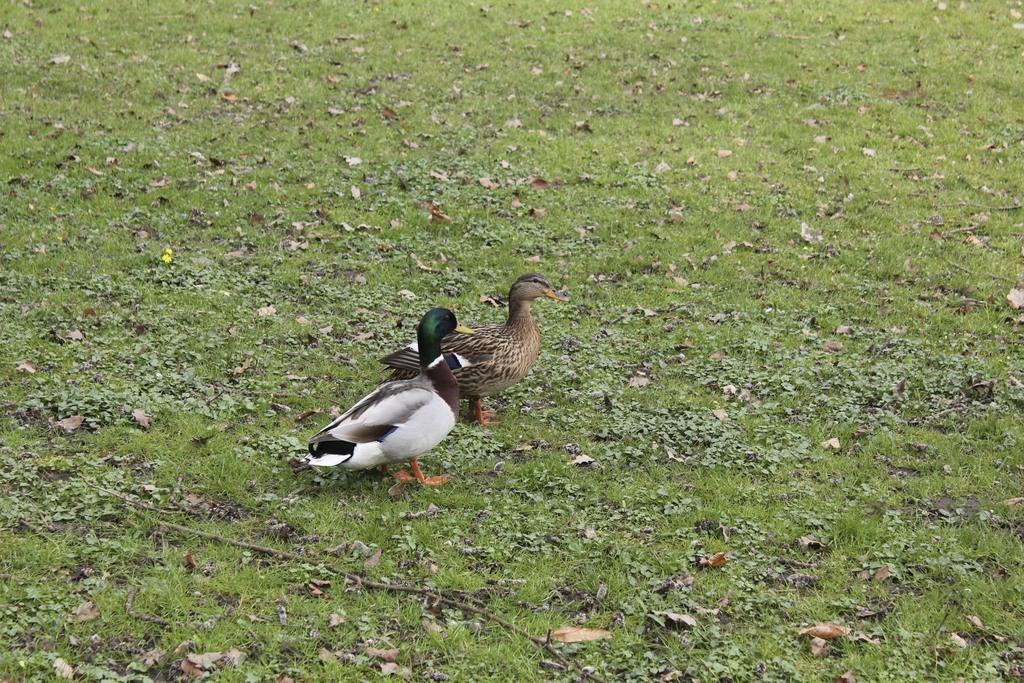How would you summarize this image in a sentence or two? This image consists of two birds. At the bottom, there is green grass on the ground. 